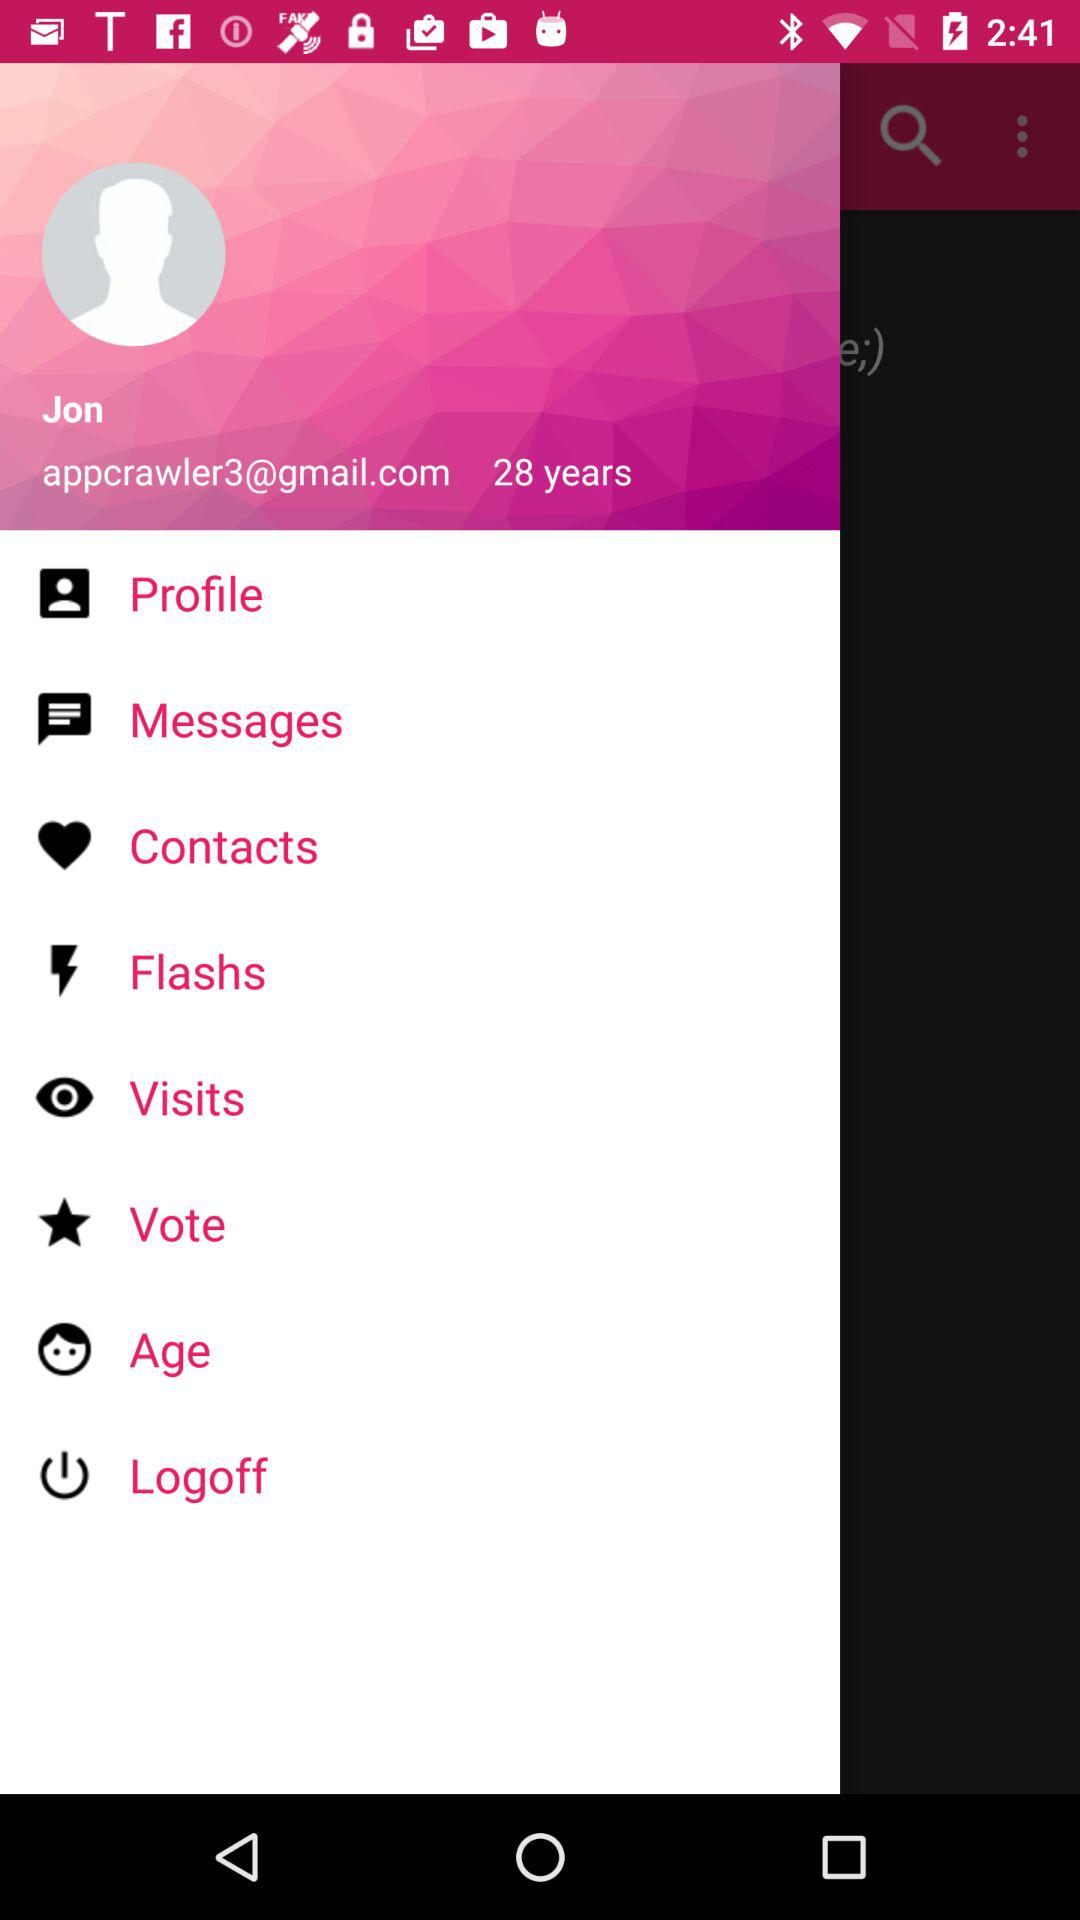What is the user name? The user name is Jon. 